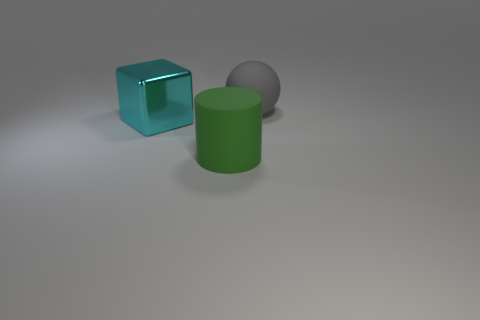What number of small things are either rubber objects or purple objects?
Provide a succinct answer. 0. There is a thing that is right of the cyan block and behind the large green thing; what is its color?
Offer a very short reply. Gray. Is the material of the ball the same as the cyan cube?
Offer a terse response. No. There is a gray object; what shape is it?
Your answer should be compact. Sphere. What number of big green matte cylinders are right of the large matte object that is right of the rubber thing that is left of the gray ball?
Offer a terse response. 0. The rubber object behind the big thing that is on the left side of the rubber thing in front of the gray sphere is what shape?
Make the answer very short. Sphere. There is a object that is behind the green thing and right of the big metallic object; what size is it?
Ensure brevity in your answer.  Large. Are there fewer small rubber cylinders than big cyan blocks?
Offer a very short reply. Yes. What size is the object behind the large cyan cube?
Your response must be concise. Large. The object that is both behind the green matte thing and in front of the rubber sphere has what shape?
Make the answer very short. Cube. 